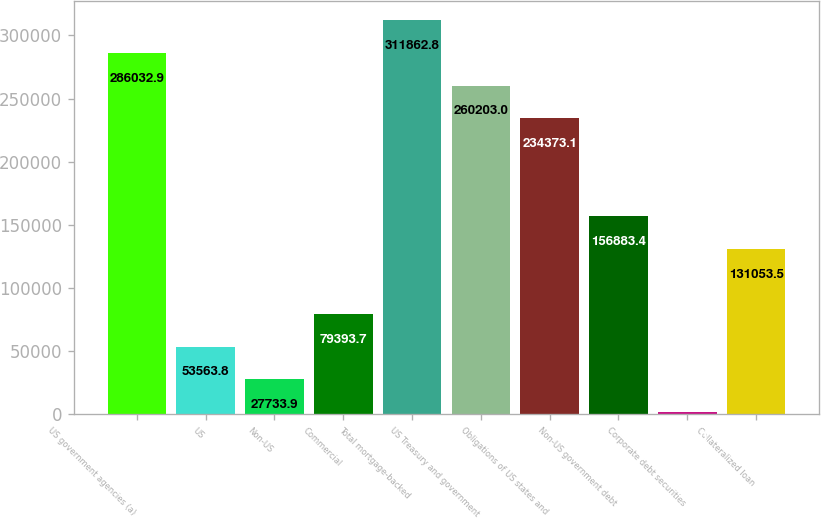<chart> <loc_0><loc_0><loc_500><loc_500><bar_chart><fcel>US government agencies (a)<fcel>US<fcel>Non-US<fcel>Commercial<fcel>Total mortgage-backed<fcel>US Treasury and government<fcel>Obligations of US states and<fcel>Non-US government debt<fcel>Corporate debt securities<fcel>Collateralized loan<nl><fcel>286033<fcel>53563.8<fcel>27733.9<fcel>79393.7<fcel>311863<fcel>260203<fcel>234373<fcel>156883<fcel>1904<fcel>131054<nl></chart> 